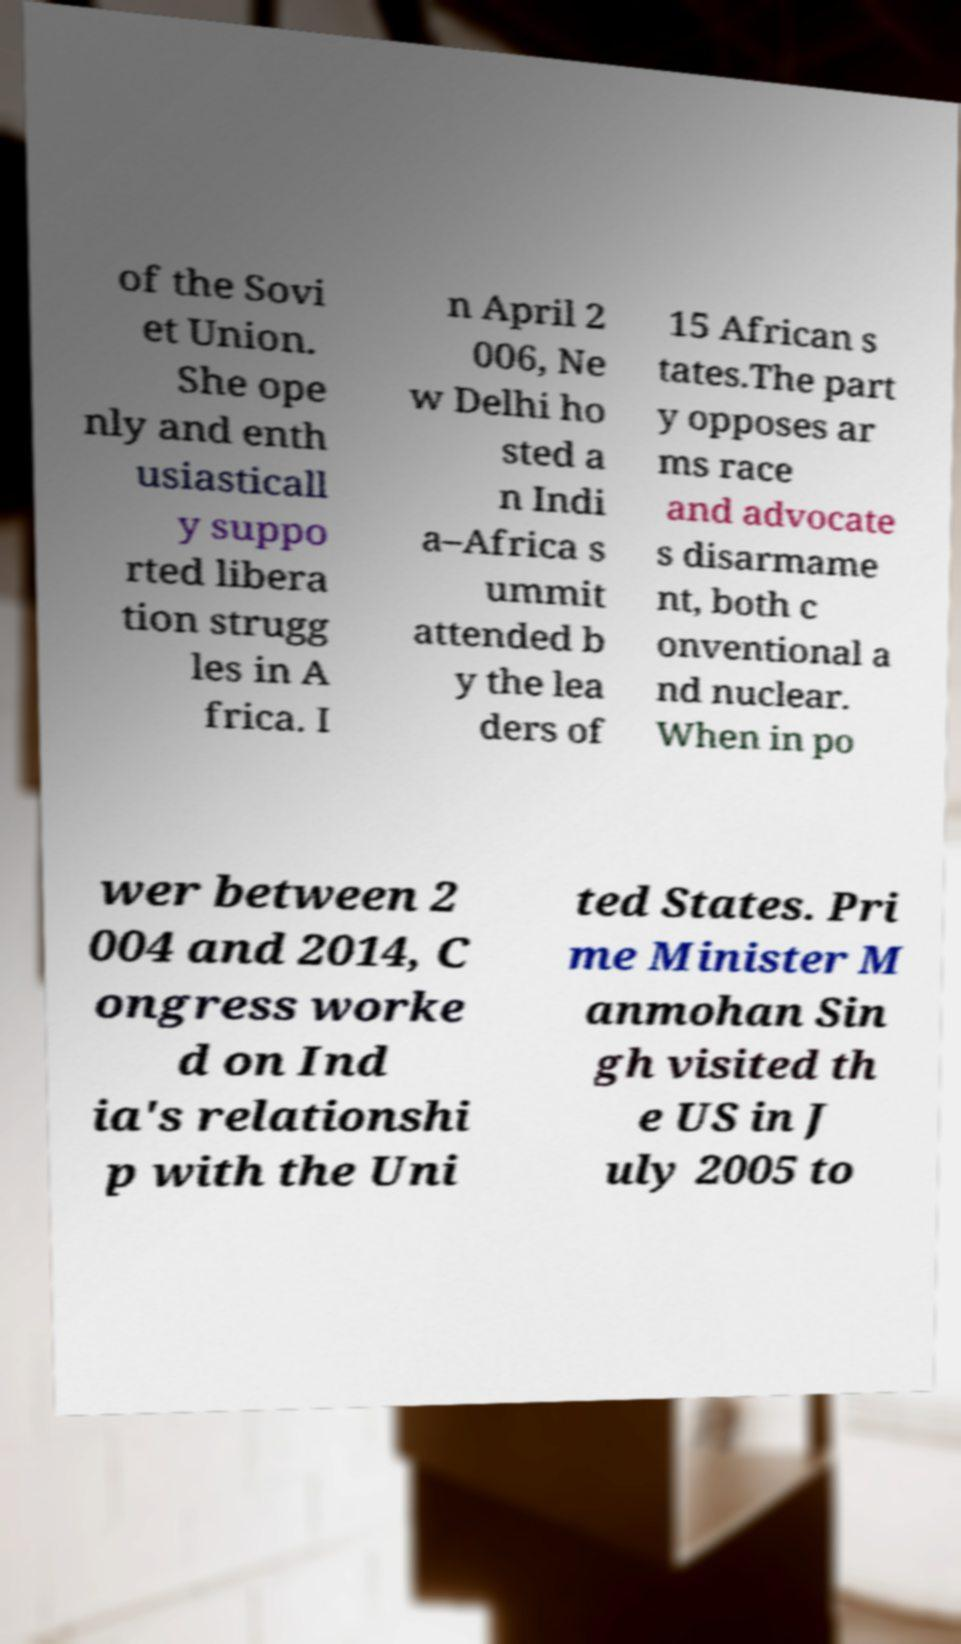Can you accurately transcribe the text from the provided image for me? of the Sovi et Union. She ope nly and enth usiasticall y suppo rted libera tion strugg les in A frica. I n April 2 006, Ne w Delhi ho sted a n Indi a–Africa s ummit attended b y the lea ders of 15 African s tates.The part y opposes ar ms race and advocate s disarmame nt, both c onventional a nd nuclear. When in po wer between 2 004 and 2014, C ongress worke d on Ind ia's relationshi p with the Uni ted States. Pri me Minister M anmohan Sin gh visited th e US in J uly 2005 to 